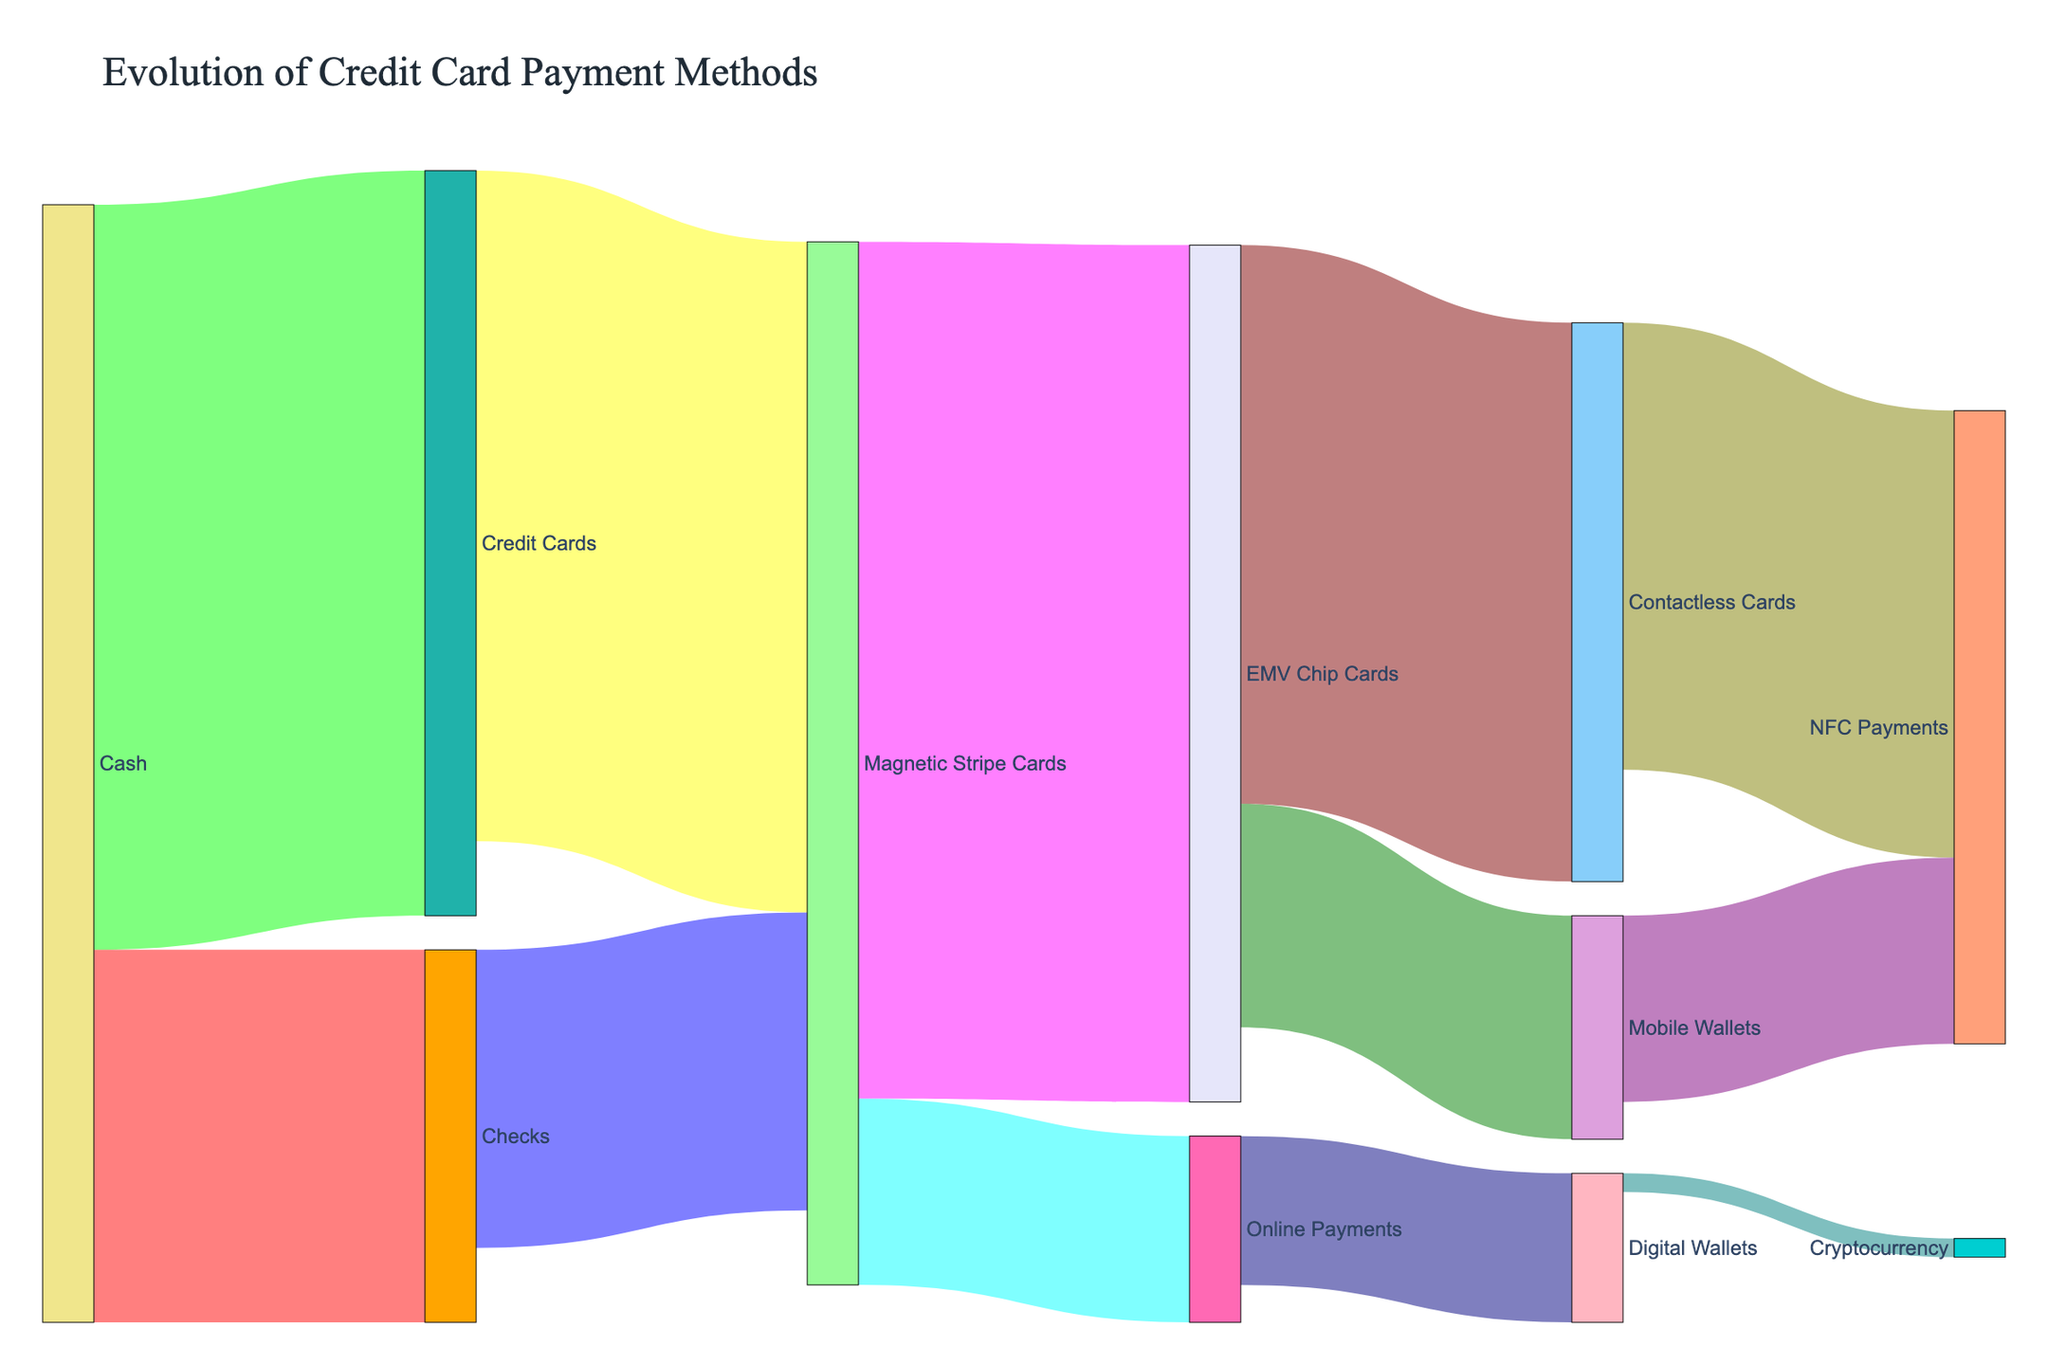How many different payment methods are illustrated in the Sankey Diagram? The Sankey Diagram shows nodes representing each payment method. Counting each unique node label gives the number of different payment methods.
Answer: 12 Which transition has the highest transaction volume? Look at the width of the links representing transaction volumes. The EMV Chip Cards to Magnetic Stripe Cards link is the widest, indicating it has the highest volume.
Answer: Magnetic Stripe Cards to EMV Chip Cards Which payment method transitions directly to Cryptocurrency? From the diagram, trace the link that ends at the Cryptocurrency node. It originates from the Digital Wallets node.
Answer: Digital Wallets Calculate the total transaction volume from Mobile Wallets. Identify all links originating from Mobile Wallets and sum their values. Mobile Wallets to NFC Payments has 500,000 and Mobile Wallets has no other outgoing link.
Answer: 500,000 By how much is the transaction volume of Magnetic Stripe Cards to EMV Chip Cards greater than Magnetic Stripe Cards to Online Payments? Find the transaction volumes: Magnetic Stripe Cards to EMV Chip Cards is 2,300,000 and Magnetic Stripe Cards to Online Payments is 500,000. Subtracting gives the difference.
Answer: 1,800,000 What are the top three payment method transitions in terms of transaction volume? Look at the width of the links; the top three widest are Magnetic Stripe Cards to EMV Chip Cards (2,300,000), Cash to Credit Cards (2,000,000), and EMV Chip Cards to Contactless Cards (1,500,000).
Answer: Magnetic Stripe Cards to EMV Chip Cards, Cash to Credit Cards, EMV Chip Cards to Contactless Cards Determine the total transaction volume involving NFC Payments. Add the transaction volumes for all paths going into or out of NFC Payments: Contactless Cards to NFC Payments (1,200,000) and Mobile Wallets to NFC Payments (500,000). Summing these values gives the total.
Answer: 1,700,000 What percentage of Digital Wallet transactions move to Cryptocurrency? Find the transition volumes from Digital Wallets: Digital Wallets to Cryptocurrency is 50,000, Digital Wallets to other methods isn't present. Hence, it's 50,000 out of 50,000.
Answer: 100% What is the most common destination method for transactions originating from EMV Chip Cards? Look at all links starting from EMV Chip Cards and see which one has the highest value: EMV Chip Cards to Contactless Cards with a value of 1,500,000.
Answer: Contactless Cards Compare the transaction volumes of Cash to Checks with Cash to Credit Cards. Which one is greater and by how much? Find the transaction volumes: Cash to Checks is 1,000,000 and Cash to Credit Cards is 2,000,000. The difference is 1,000,000 with Cash to Credit Cards being greater.
Answer: Cash to Credit Cards by 1,000,000 